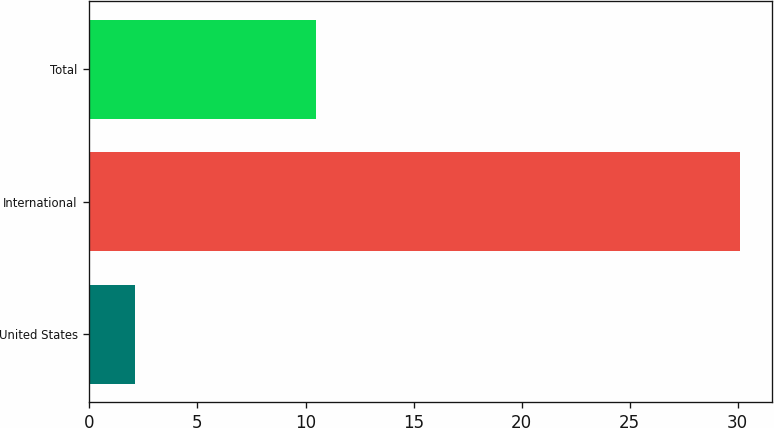Convert chart. <chart><loc_0><loc_0><loc_500><loc_500><bar_chart><fcel>United States<fcel>International<fcel>Total<nl><fcel>2.1<fcel>30.1<fcel>10.5<nl></chart> 